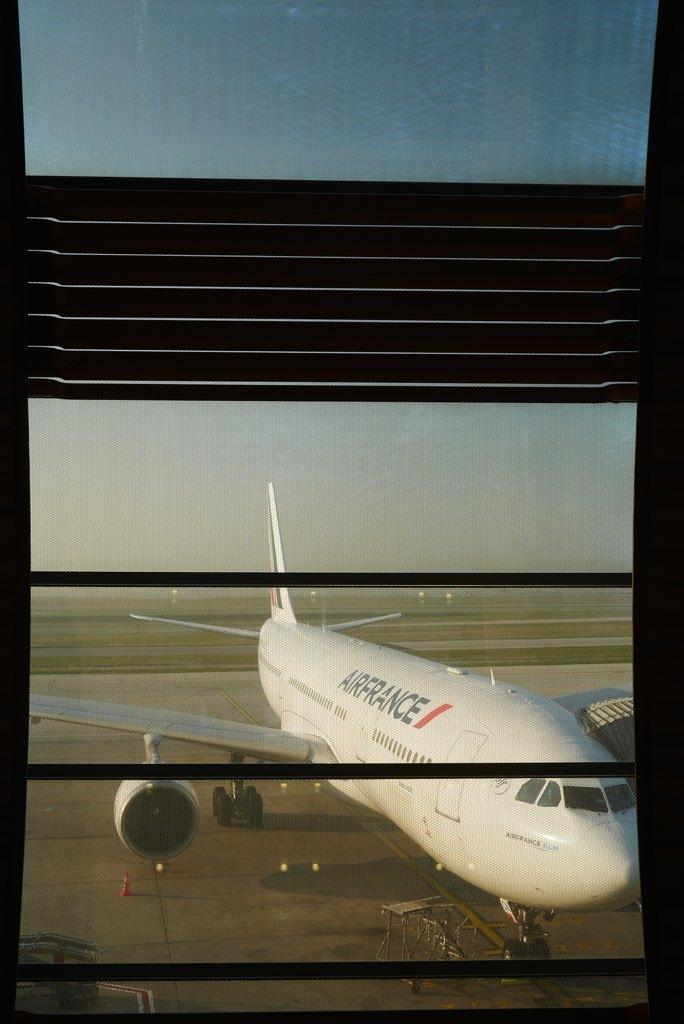<image>
Write a terse but informative summary of the picture. A view through a window looks out onto an Air France plane. 